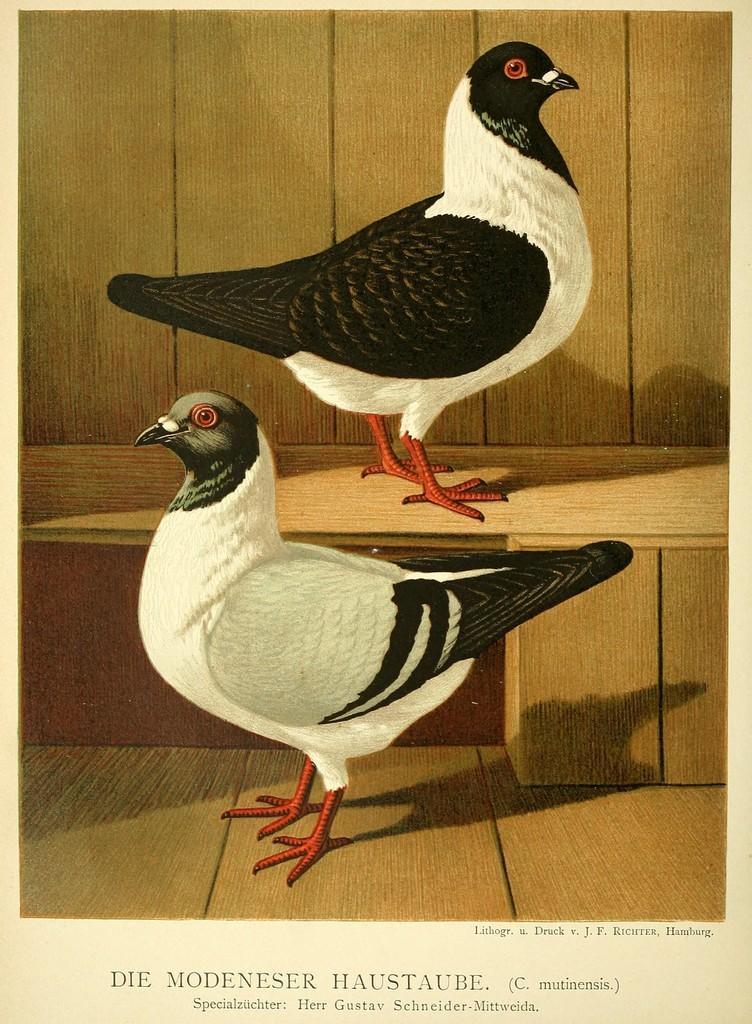How would you summarize this image in a sentence or two? In this image there is an art of two birds. At the bottom there is text. There are two birds standing on the wooden floor one above the other. 